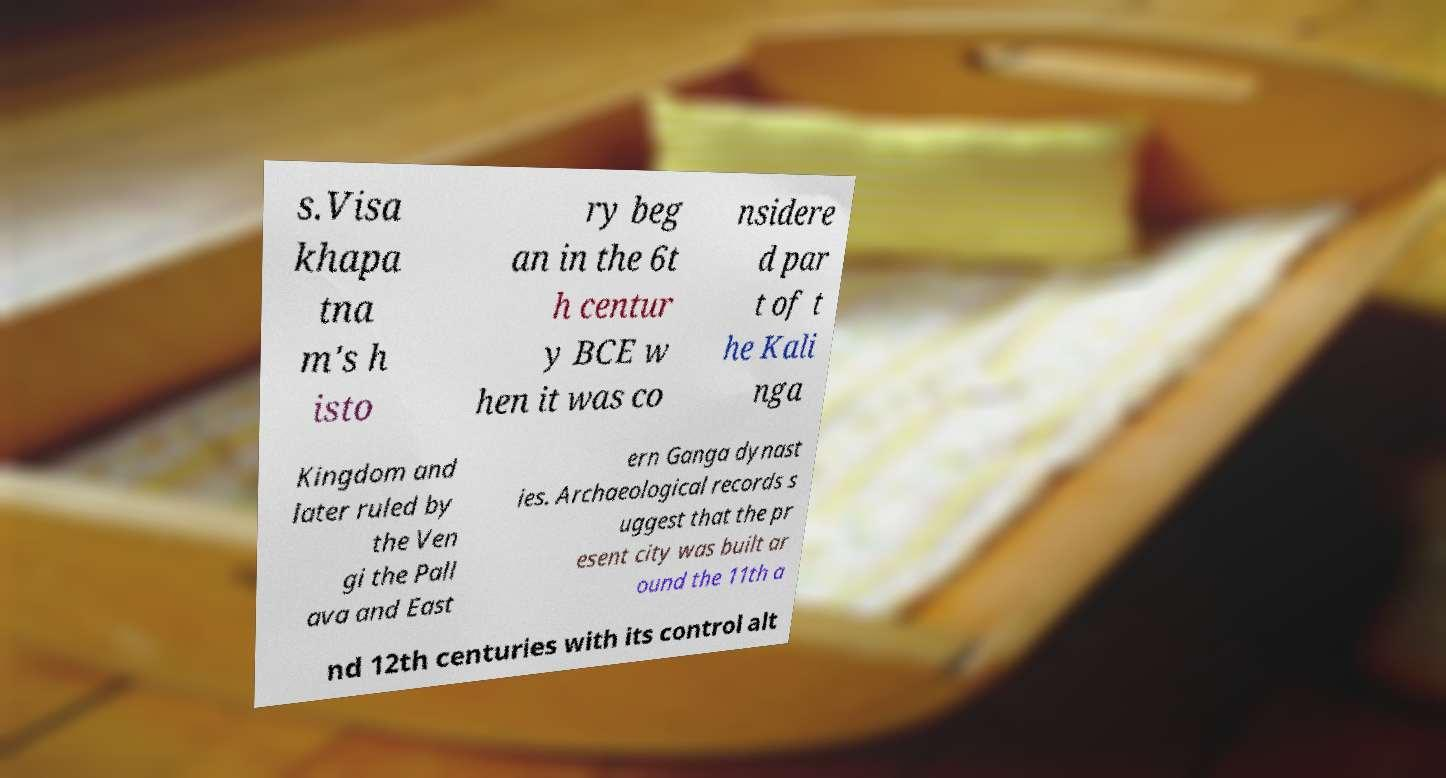I need the written content from this picture converted into text. Can you do that? s.Visa khapa tna m's h isto ry beg an in the 6t h centur y BCE w hen it was co nsidere d par t of t he Kali nga Kingdom and later ruled by the Ven gi the Pall ava and East ern Ganga dynast ies. Archaeological records s uggest that the pr esent city was built ar ound the 11th a nd 12th centuries with its control alt 